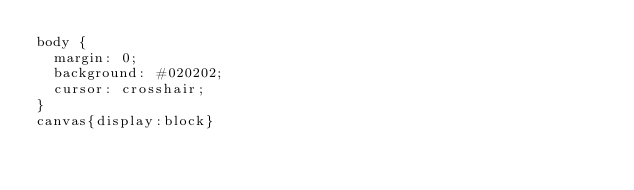<code> <loc_0><loc_0><loc_500><loc_500><_CSS_>body {
  margin: 0;
  background: #020202;
  cursor: crosshair;
}
canvas{display:block}</code> 